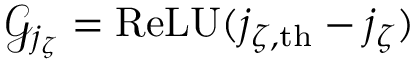<formula> <loc_0><loc_0><loc_500><loc_500>\mathcal { G } _ { j _ { \zeta } } = R e L U ( j _ { \zeta , t h } - j _ { \zeta } )</formula> 